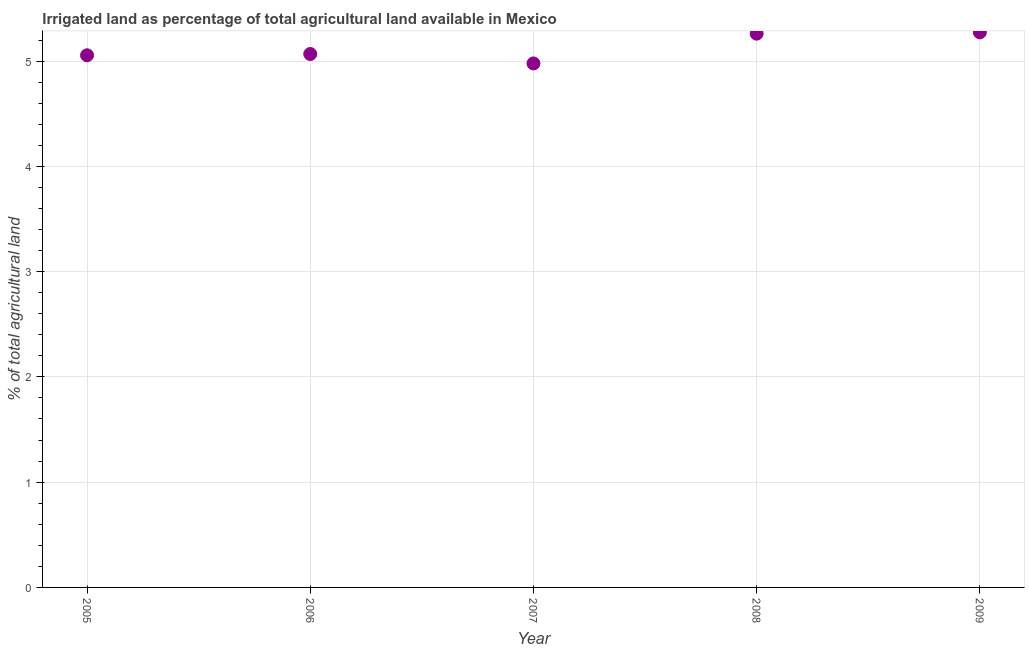What is the percentage of agricultural irrigated land in 2007?
Ensure brevity in your answer.  4.98. Across all years, what is the maximum percentage of agricultural irrigated land?
Offer a very short reply. 5.27. Across all years, what is the minimum percentage of agricultural irrigated land?
Offer a very short reply. 4.98. In which year was the percentage of agricultural irrigated land maximum?
Keep it short and to the point. 2009. In which year was the percentage of agricultural irrigated land minimum?
Give a very brief answer. 2007. What is the sum of the percentage of agricultural irrigated land?
Provide a short and direct response. 25.63. What is the difference between the percentage of agricultural irrigated land in 2006 and 2009?
Ensure brevity in your answer.  -0.21. What is the average percentage of agricultural irrigated land per year?
Make the answer very short. 5.13. What is the median percentage of agricultural irrigated land?
Your answer should be very brief. 5.07. Do a majority of the years between 2008 and 2005 (inclusive) have percentage of agricultural irrigated land greater than 1.8 %?
Your response must be concise. Yes. What is the ratio of the percentage of agricultural irrigated land in 2005 to that in 2009?
Ensure brevity in your answer.  0.96. Is the percentage of agricultural irrigated land in 2005 less than that in 2007?
Give a very brief answer. No. What is the difference between the highest and the second highest percentage of agricultural irrigated land?
Offer a very short reply. 0.01. What is the difference between the highest and the lowest percentage of agricultural irrigated land?
Make the answer very short. 0.29. In how many years, is the percentage of agricultural irrigated land greater than the average percentage of agricultural irrigated land taken over all years?
Your answer should be very brief. 2. What is the difference between two consecutive major ticks on the Y-axis?
Provide a succinct answer. 1. Are the values on the major ticks of Y-axis written in scientific E-notation?
Your answer should be very brief. No. Does the graph contain grids?
Provide a succinct answer. Yes. What is the title of the graph?
Keep it short and to the point. Irrigated land as percentage of total agricultural land available in Mexico. What is the label or title of the Y-axis?
Give a very brief answer. % of total agricultural land. What is the % of total agricultural land in 2005?
Ensure brevity in your answer.  5.05. What is the % of total agricultural land in 2006?
Provide a succinct answer. 5.07. What is the % of total agricultural land in 2007?
Make the answer very short. 4.98. What is the % of total agricultural land in 2008?
Your response must be concise. 5.26. What is the % of total agricultural land in 2009?
Offer a terse response. 5.27. What is the difference between the % of total agricultural land in 2005 and 2006?
Your answer should be very brief. -0.01. What is the difference between the % of total agricultural land in 2005 and 2007?
Offer a terse response. 0.08. What is the difference between the % of total agricultural land in 2005 and 2008?
Your answer should be very brief. -0.21. What is the difference between the % of total agricultural land in 2005 and 2009?
Ensure brevity in your answer.  -0.22. What is the difference between the % of total agricultural land in 2006 and 2007?
Your answer should be very brief. 0.09. What is the difference between the % of total agricultural land in 2006 and 2008?
Ensure brevity in your answer.  -0.19. What is the difference between the % of total agricultural land in 2006 and 2009?
Make the answer very short. -0.21. What is the difference between the % of total agricultural land in 2007 and 2008?
Your answer should be compact. -0.28. What is the difference between the % of total agricultural land in 2007 and 2009?
Offer a terse response. -0.29. What is the difference between the % of total agricultural land in 2008 and 2009?
Offer a terse response. -0.01. What is the ratio of the % of total agricultural land in 2005 to that in 2008?
Keep it short and to the point. 0.96. What is the ratio of the % of total agricultural land in 2005 to that in 2009?
Make the answer very short. 0.96. What is the ratio of the % of total agricultural land in 2006 to that in 2008?
Keep it short and to the point. 0.96. What is the ratio of the % of total agricultural land in 2006 to that in 2009?
Ensure brevity in your answer.  0.96. What is the ratio of the % of total agricultural land in 2007 to that in 2008?
Make the answer very short. 0.95. What is the ratio of the % of total agricultural land in 2007 to that in 2009?
Provide a short and direct response. 0.94. What is the ratio of the % of total agricultural land in 2008 to that in 2009?
Offer a terse response. 1. 